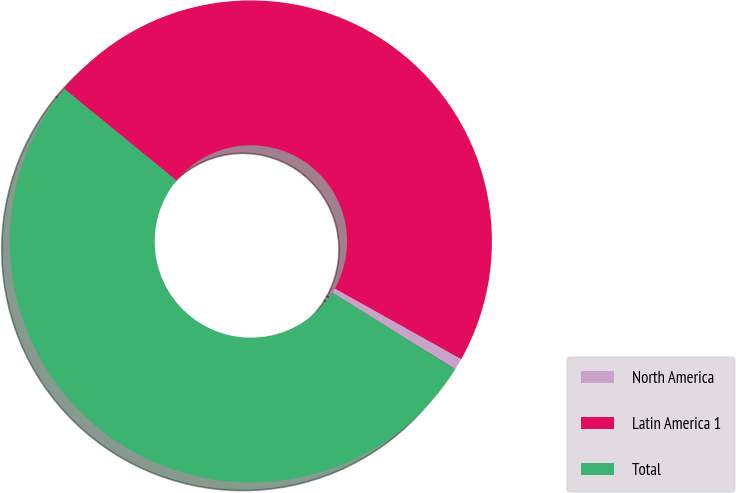Convert chart. <chart><loc_0><loc_0><loc_500><loc_500><pie_chart><fcel>North America<fcel>Latin America 1<fcel>Total<nl><fcel>0.78%<fcel>47.2%<fcel>52.02%<nl></chart> 